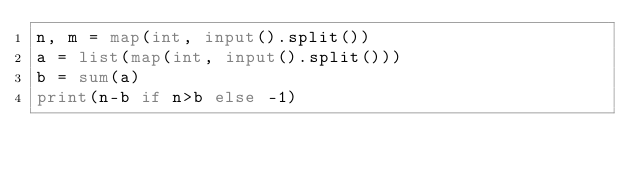Convert code to text. <code><loc_0><loc_0><loc_500><loc_500><_Python_>n, m = map(int, input().split())
a = list(map(int, input().split()))
b = sum(a)
print(n-b if n>b else -1)</code> 